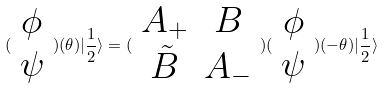Convert formula to latex. <formula><loc_0><loc_0><loc_500><loc_500>( \begin{array} { c } \phi \\ \psi \end{array} ) ( \theta ) | \frac { 1 } { 2 } \rangle = ( \begin{array} { c c } A _ { + } & B \\ \tilde { B } & A _ { - } \end{array} ) ( \begin{array} { c } \phi \\ \psi \end{array} ) ( - \theta ) | \frac { 1 } { 2 } \rangle</formula> 